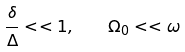Convert formula to latex. <formula><loc_0><loc_0><loc_500><loc_500>\frac { \delta } { \Delta } < < 1 , \quad \Omega _ { 0 } < < \omega</formula> 